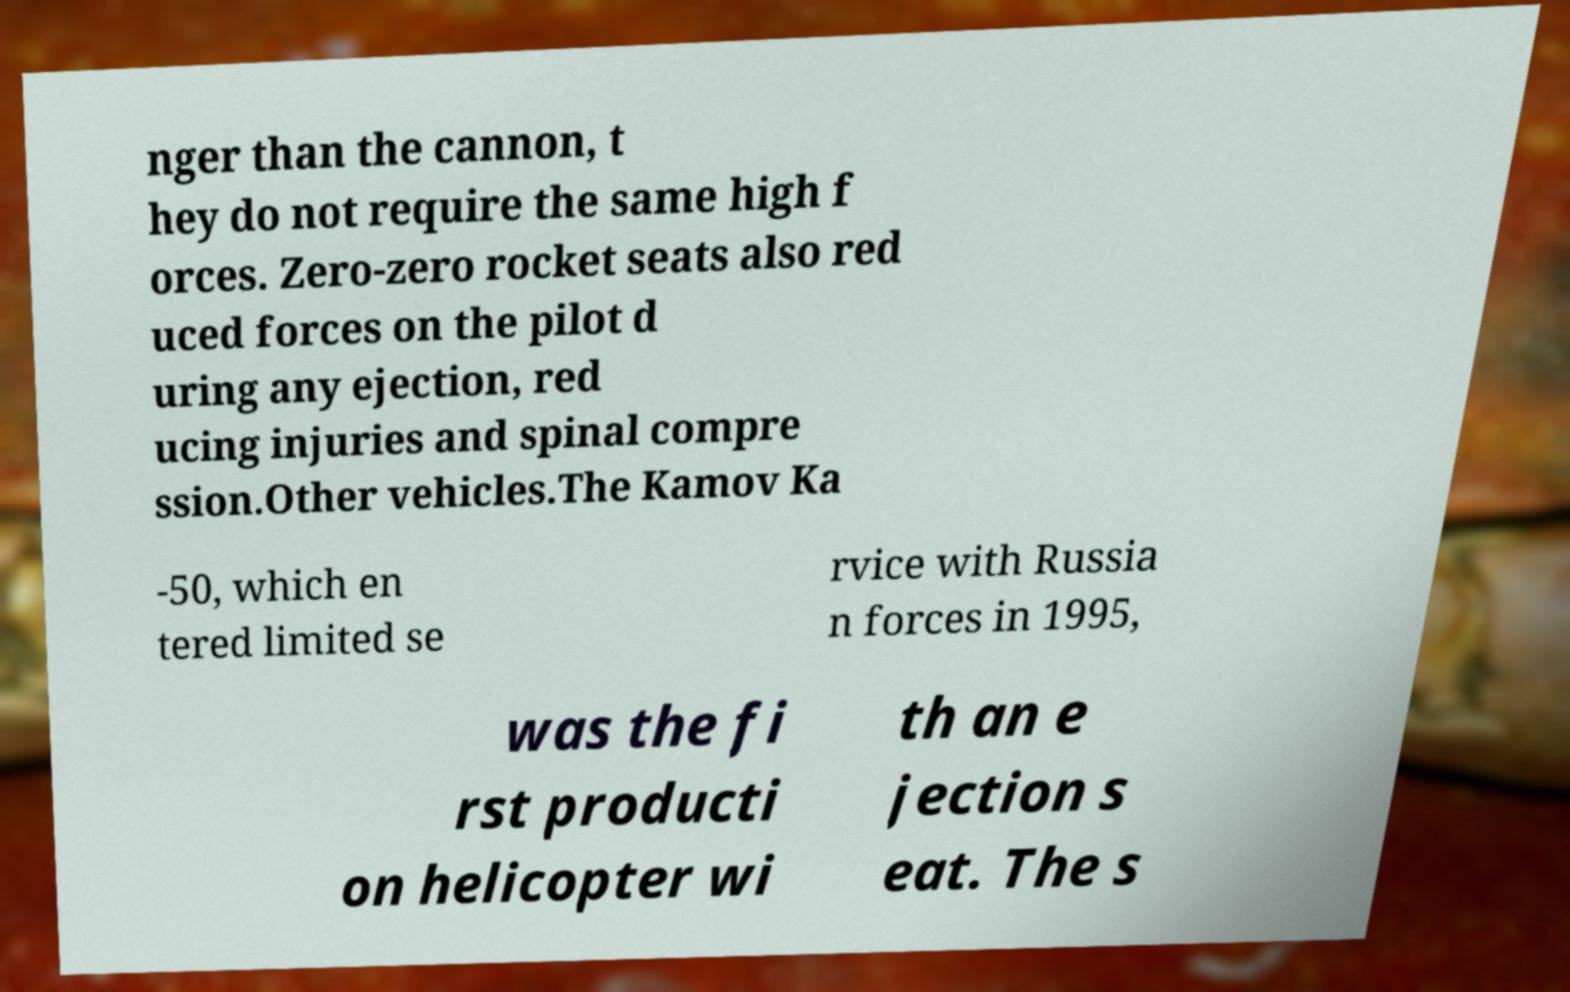I need the written content from this picture converted into text. Can you do that? nger than the cannon, t hey do not require the same high f orces. Zero-zero rocket seats also red uced forces on the pilot d uring any ejection, red ucing injuries and spinal compre ssion.Other vehicles.The Kamov Ka -50, which en tered limited se rvice with Russia n forces in 1995, was the fi rst producti on helicopter wi th an e jection s eat. The s 